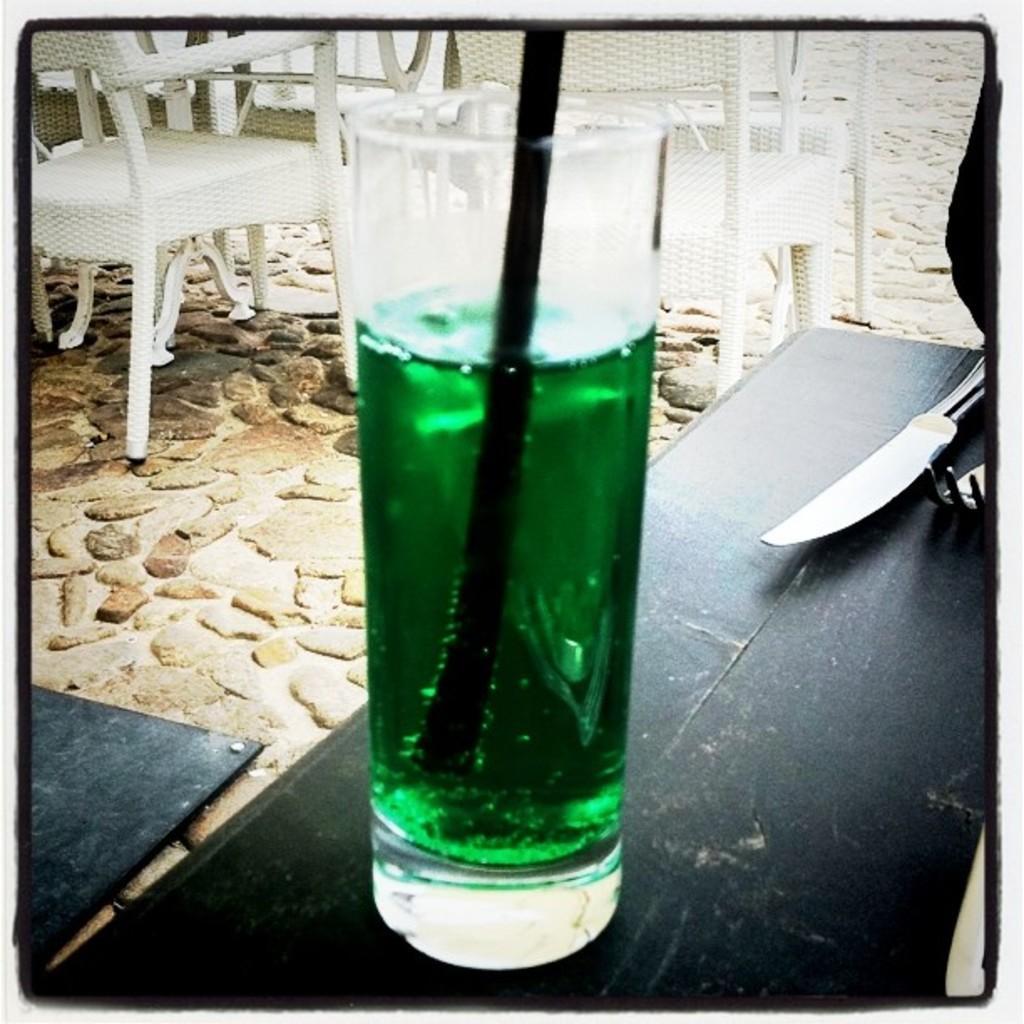How would you summarize this image in a sentence or two? In this image, there is a table contains a knife, fork and glass. There are some chairs at the top of the image. 